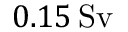<formula> <loc_0><loc_0><loc_500><loc_500>0 . 1 5 \, S v</formula> 